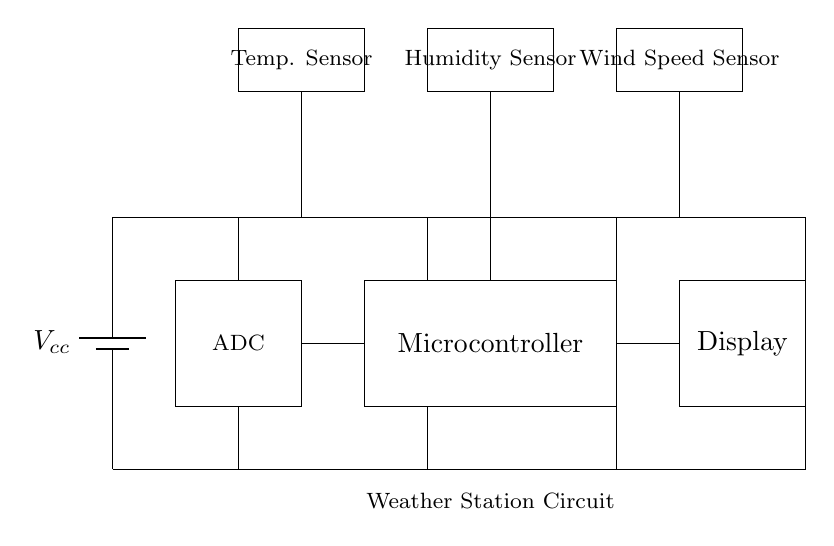What are the components of this circuit? The circuit comprises a microcontroller, temperature sensor, humidity sensor, wind speed sensor, analog-to-digital converter, battery, and display. Each component has a specific role in measuring and displaying weather data.
Answer: microcontroller, temperature sensor, humidity sensor, wind speed sensor, ADC, battery, display What does the battery supply? The battery provides the necessary voltage to power the entire circuit, ensuring that each component operates effectively. In the circuit diagram, the battery is indicated at the top left corner with a label for voltage supply.
Answer: voltage Which sensors are integrated into the weather station? The weather station integrates three types of sensors: a temperature sensor, a humidity sensor, and a wind speed sensor. These sensors collect vital environmental data necessary for weather monitoring.
Answer: temperature sensor, humidity sensor, wind speed sensor How does data from the sensors reach the display? Data from the sensors is sent to the analog-to-digital converter (ADC), where it is transformed into a digital signal that the microcontroller processes. After processing, the microcontroller relays the results to the display for visualization.
Answer: through ADC to microcontroller What role does the ADC play in the circuit? The ADC converts the analog sensor signals into digital data that the microcontroller can interpret and utilize. Without the ADC, the microcontroller wouldn't be able to process the data from the sensors since they output analog signals.
Answer: data conversion How does the circuit handle power distribution? The circuit manages power distribution through a series of connections that supply voltage to all components. The power supply connections branch out to each component, ensuring they receive the required power for operation.
Answer: through power connections 